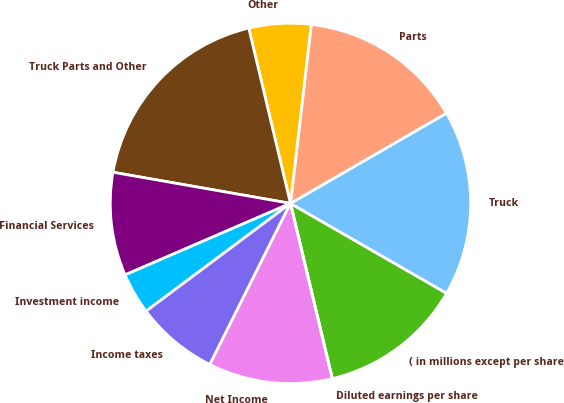Convert chart to OTSL. <chart><loc_0><loc_0><loc_500><loc_500><pie_chart><fcel>( in millions except per share<fcel>Truck<fcel>Parts<fcel>Other<fcel>Truck Parts and Other<fcel>Financial Services<fcel>Investment income<fcel>Income taxes<fcel>Net Income<fcel>Diluted earnings per share<nl><fcel>12.96%<fcel>16.66%<fcel>14.81%<fcel>5.56%<fcel>18.52%<fcel>9.26%<fcel>3.71%<fcel>7.41%<fcel>11.11%<fcel>0.0%<nl></chart> 